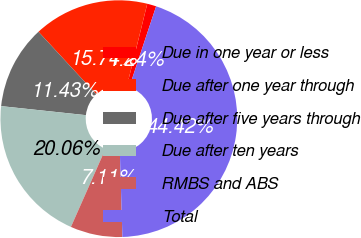<chart> <loc_0><loc_0><loc_500><loc_500><pie_chart><fcel>Due in one year or less<fcel>Due after one year through<fcel>Due after five years through<fcel>Due after ten years<fcel>RMBS and ABS<fcel>Total<nl><fcel>1.24%<fcel>15.74%<fcel>11.43%<fcel>20.06%<fcel>7.11%<fcel>44.42%<nl></chart> 